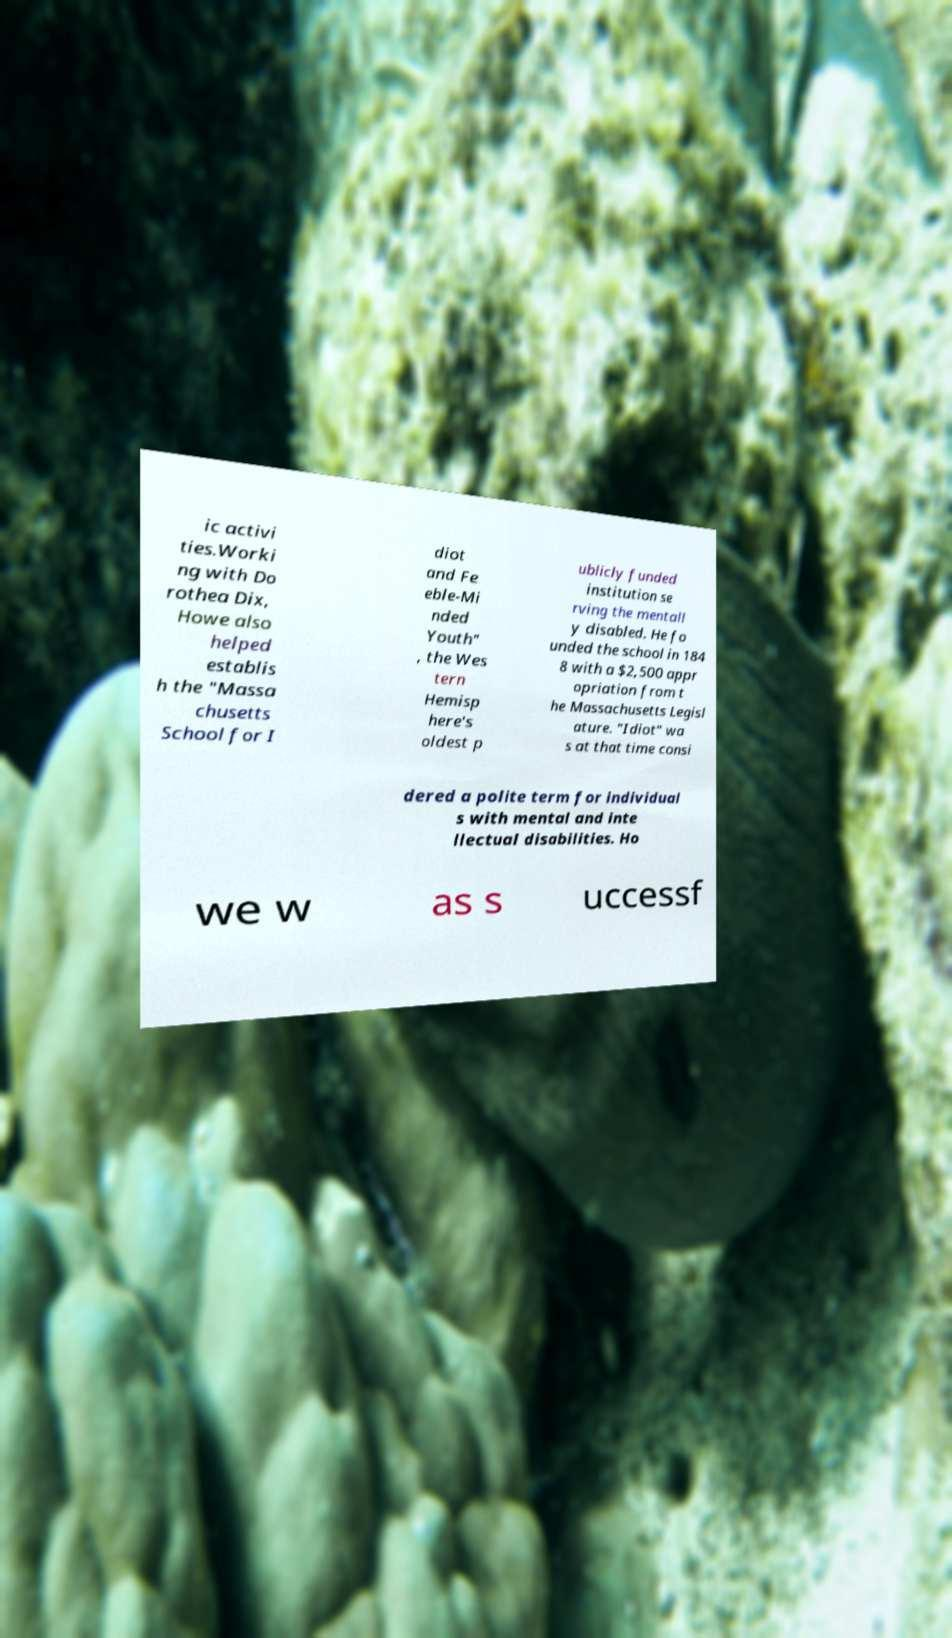What messages or text are displayed in this image? I need them in a readable, typed format. ic activi ties.Worki ng with Do rothea Dix, Howe also helped establis h the "Massa chusetts School for I diot and Fe eble-Mi nded Youth" , the Wes tern Hemisp here's oldest p ublicly funded institution se rving the mentall y disabled. He fo unded the school in 184 8 with a $2,500 appr opriation from t he Massachusetts Legisl ature. "Idiot" wa s at that time consi dered a polite term for individual s with mental and inte llectual disabilities. Ho we w as s uccessf 